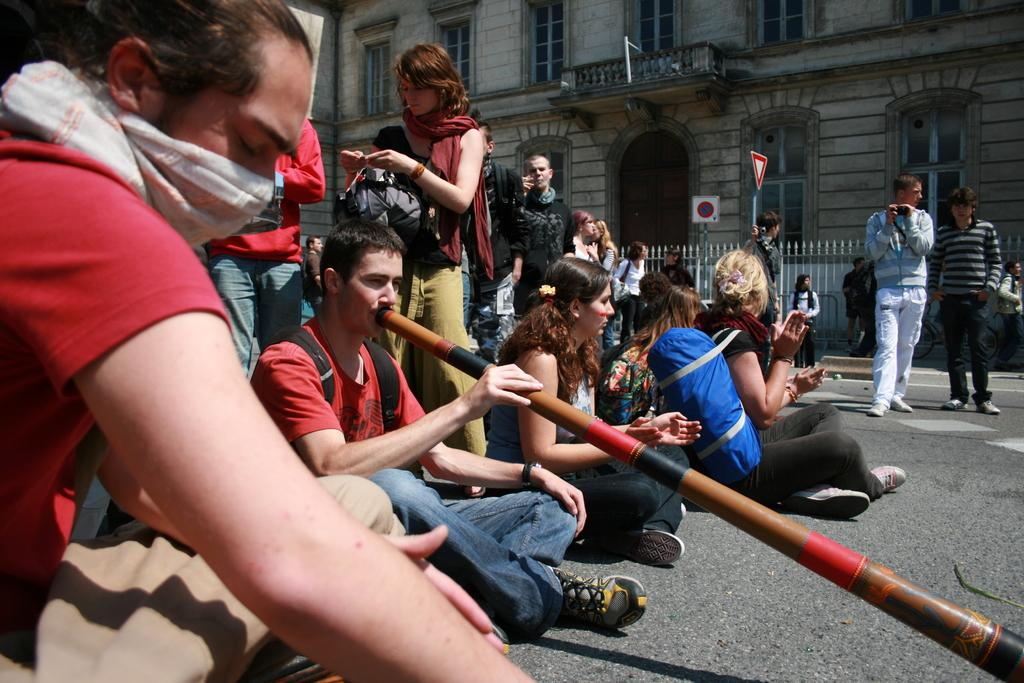What are the people in the image doing on the road? There are people sitting and standing on the road in the image. What can be seen in the background of the image? There are buildings, sign boards, and grills in the background of the image. What type of sponge is being used by the team in the image? There is no sponge or team present in the image. How many sons are visible in the image? There is no reference to a son or any individuals in the image. 